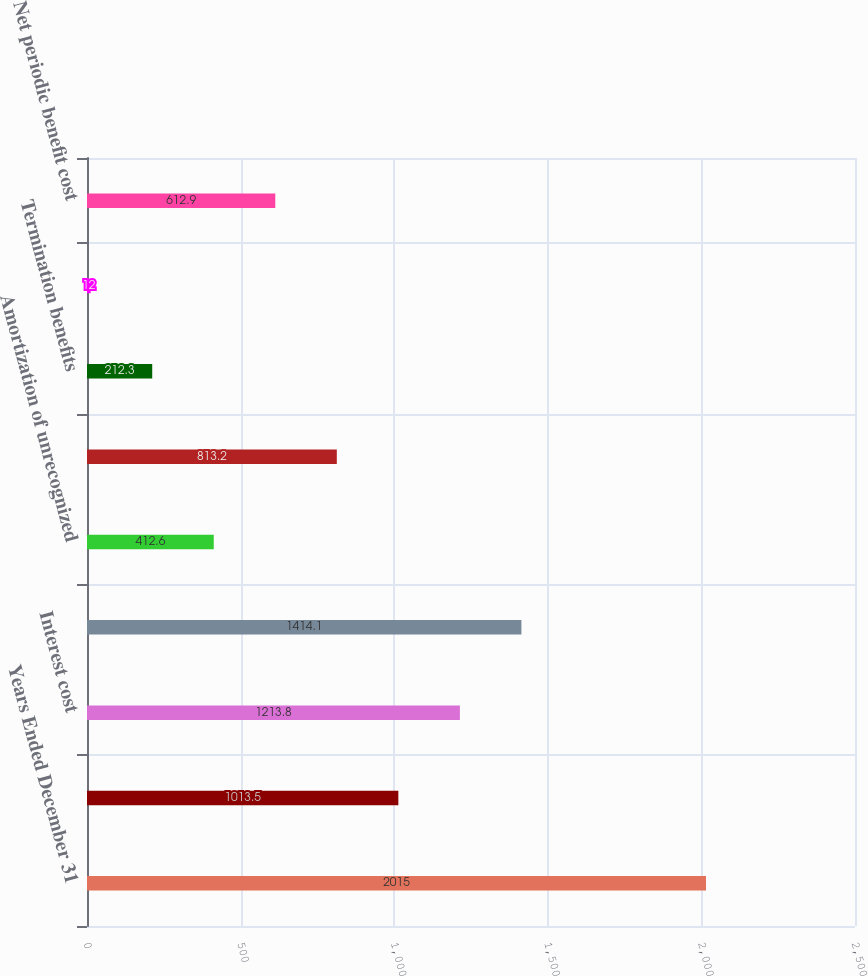<chart> <loc_0><loc_0><loc_500><loc_500><bar_chart><fcel>Years Ended December 31<fcel>Service cost<fcel>Interest cost<fcel>Expected return on plan assets<fcel>Amortization of unrecognized<fcel>Net loss amortization<fcel>Termination benefits<fcel>Curtailments<fcel>Net periodic benefit cost<nl><fcel>2015<fcel>1013.5<fcel>1213.8<fcel>1414.1<fcel>412.6<fcel>813.2<fcel>212.3<fcel>12<fcel>612.9<nl></chart> 